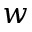Convert formula to latex. <formula><loc_0><loc_0><loc_500><loc_500>w</formula> 